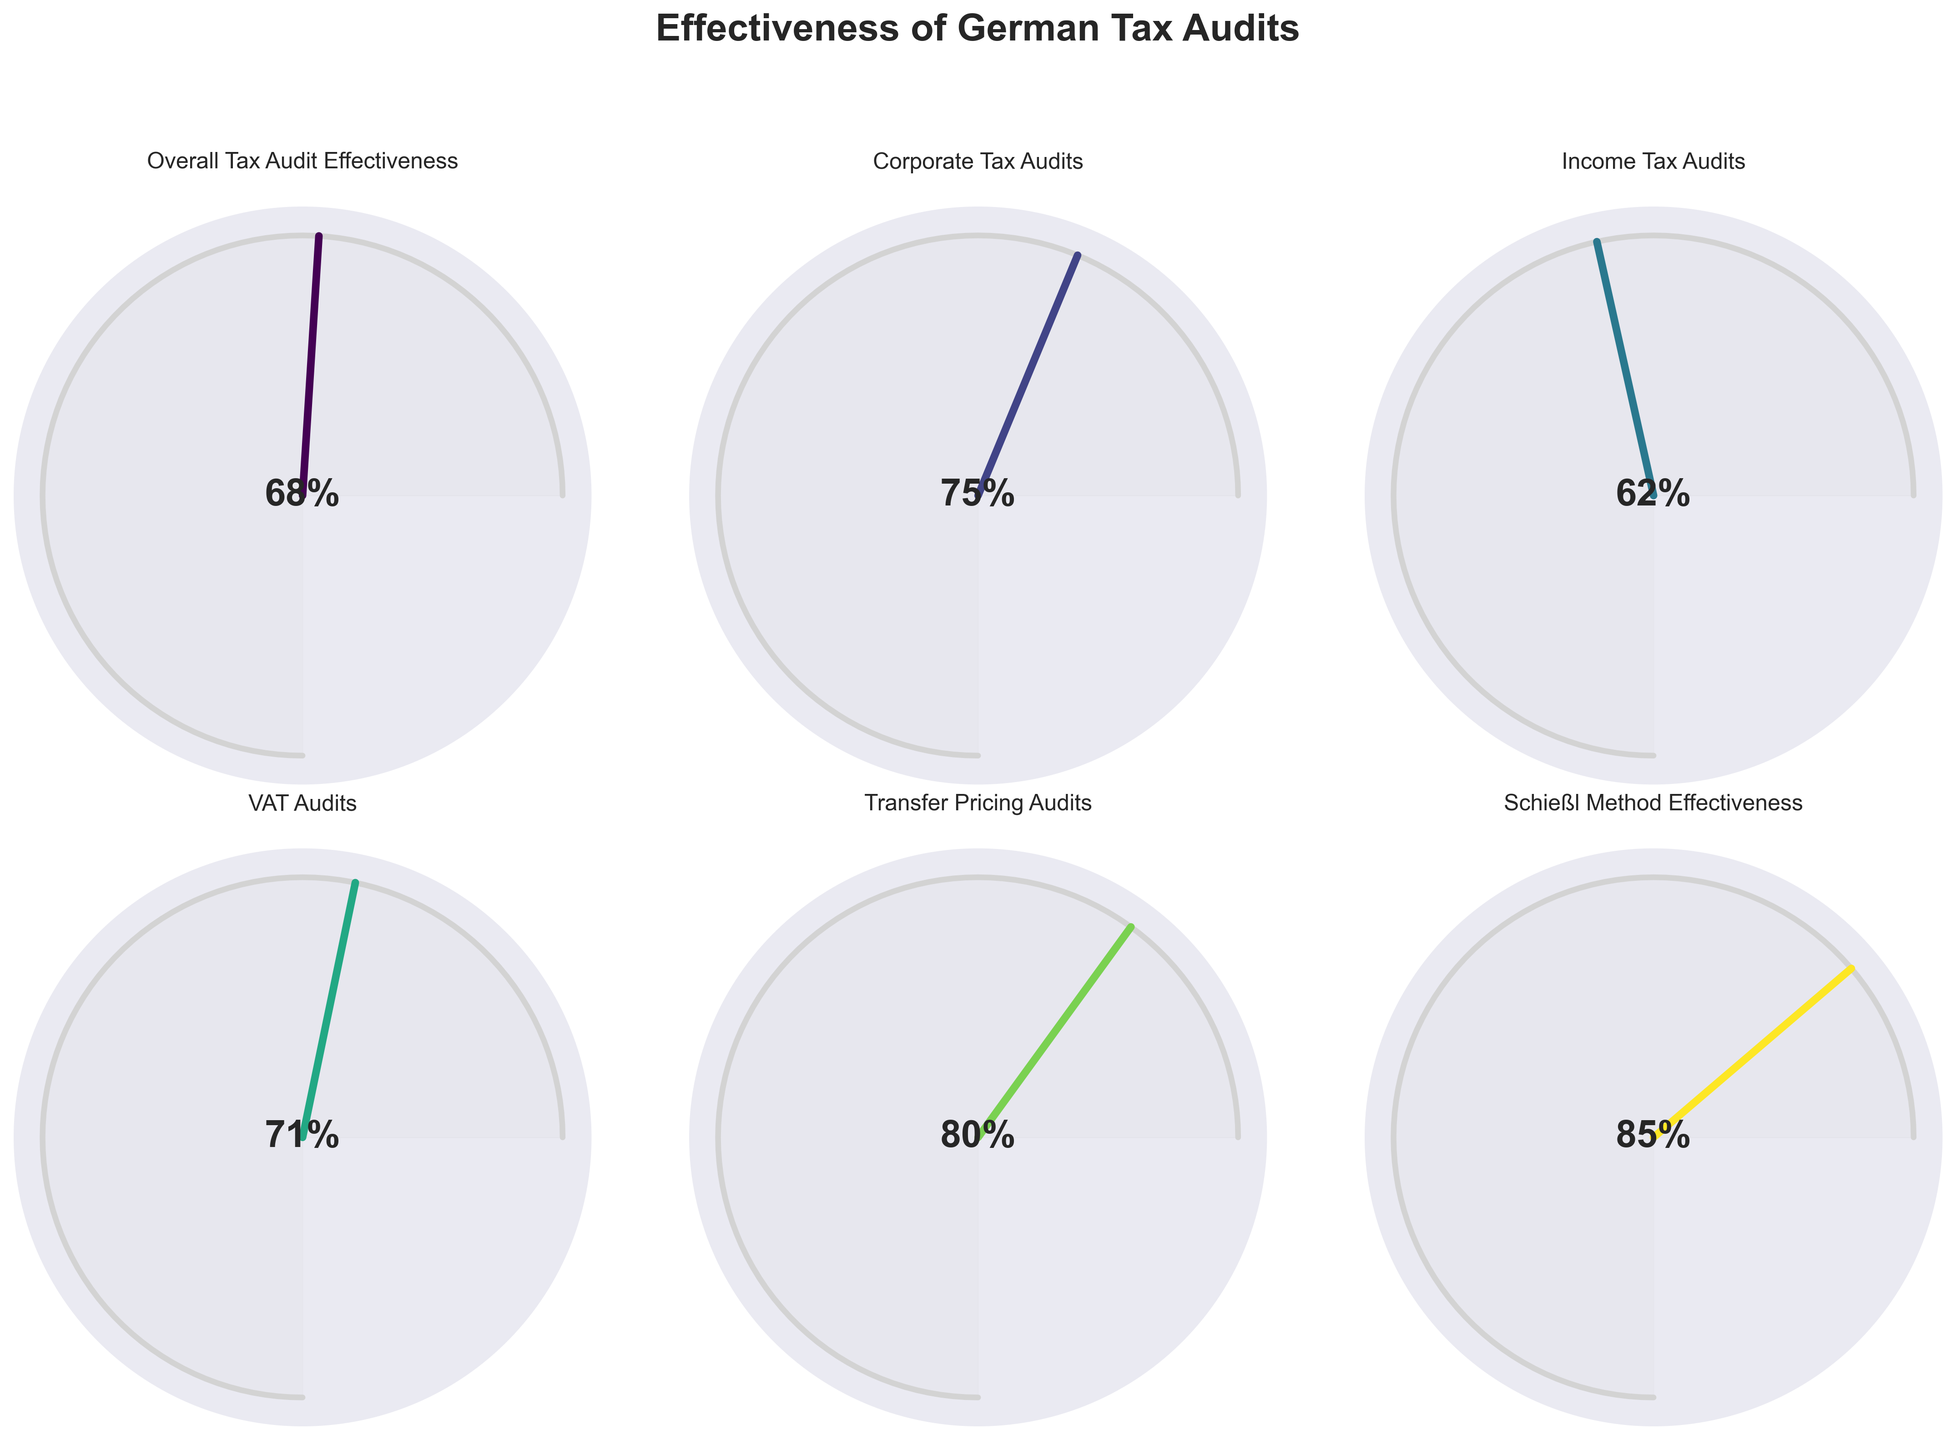What is the effectiveness percentage for Corporate Tax Audits? The category "Corporate Tax Audits" shows its effectiveness percentage directly on the gauge chart, which is a number in the middle of the gauge. It's color-coded in the gauge chart.
Answer: 75% How does the effectiveness of Income Tax Audits compare to that of VAT Audits? To compare these two, look at the effectiveness percentages in the middle of their respective gauge charts. Income Tax Audits show 62%, and VAT Audits show 71%.
Answer: VAT Audits are more effective What is the title of the figure? The title is prominently displayed at the top center of the figure.
Answer: Effectiveness of German Tax Audits Which category has the highest effectiveness percentage, and what is that percentage? To find the highest value, compare all the effectiveness percentages shown in the middle of each gauge. "Schießl Method Effectiveness" has the highest value.
Answer: Schießl Method Effectiveness, 85% Calculate the average effectiveness percentage across all categories. Add all the effectiveness values: (68 + 75 + 62 + 71 + 80 + 85) = 441, then divide by the number of categories, 6. The average is 441/6 = 73.5
Answer: 73.5% How many categories have an effectiveness percentage of 70% or higher? Count the number of gauge charts with a percentage of 70% or higher: Corporate Tax Audits (75%), VAT Audits (71%), Transfer Pricing Audits (80%), Schießl Method Effectiveness (85%).
Answer: 4 Which category lies close to the average effectiveness percentage across all categories, and what is its value? The average effectiveness is 73.5%, so look for a category value close to this. VAT Audits have a percentage of 71%, which is closest to the average.
Answer: VAT Audits, 71% What color scheme is used in the gauge charts? The chart employs a specific color map for the sections of the gauges, appearing as gradients likely from a color map like 'viridis' ranging from blue to green to yellow.
Answer: Viridis color scheme Compare the effectiveness of Transfer Pricing Audits with the Overall Tax Audit Effectiveness. Which one is higher, and by how much? Transfer Pricing Audits are 80%, and Overall Tax Audit Effectiveness is 68%. Subtract the values to find the difference: 80% - 68% = 12%.
Answer: Transfer Pricing Audits, 12% Frankly speaking, which category shows the least effectiveness percentage? To determine the least effective, find the lowest effectiveness percentage in the gauge charts. Income Tax Audits have the lowest percentage.
Answer: Income Tax Audits, 62% 